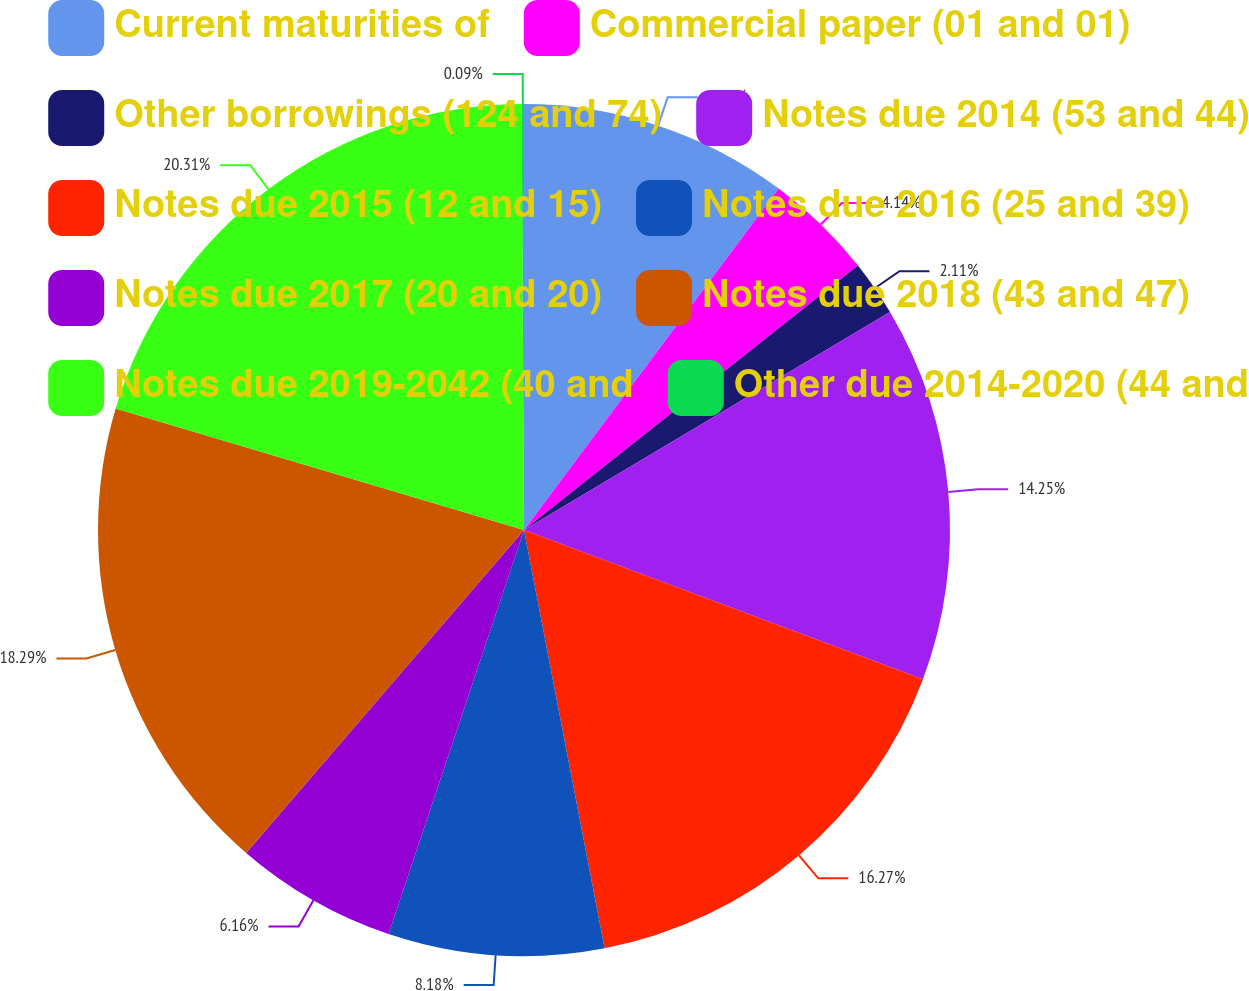Convert chart. <chart><loc_0><loc_0><loc_500><loc_500><pie_chart><fcel>Current maturities of<fcel>Commercial paper (01 and 01)<fcel>Other borrowings (124 and 74)<fcel>Notes due 2014 (53 and 44)<fcel>Notes due 2015 (12 and 15)<fcel>Notes due 2016 (25 and 39)<fcel>Notes due 2017 (20 and 20)<fcel>Notes due 2018 (43 and 47)<fcel>Notes due 2019-2042 (40 and<fcel>Other due 2014-2020 (44 and<nl><fcel>10.2%<fcel>4.14%<fcel>2.11%<fcel>14.25%<fcel>16.27%<fcel>8.18%<fcel>6.16%<fcel>18.29%<fcel>20.31%<fcel>0.09%<nl></chart> 